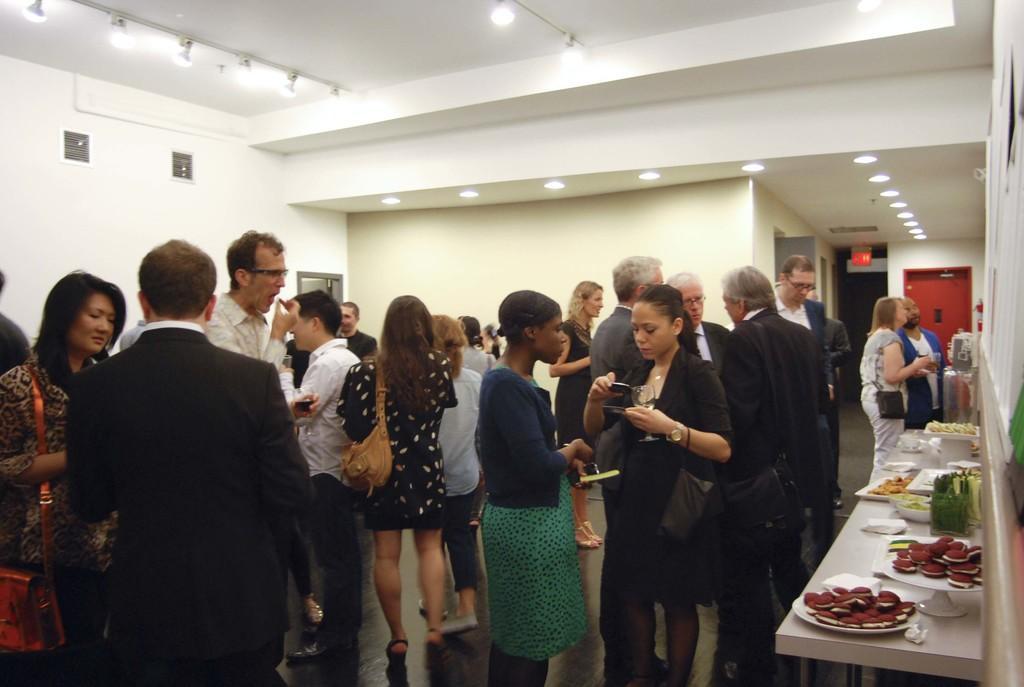Please provide a concise description of this image. In this picture we can see few people are standing on the floor. Here we can see a table, plates, bowls, trays, tissue papers, and food items. In the background we can see wall, lights, board, and doors. 